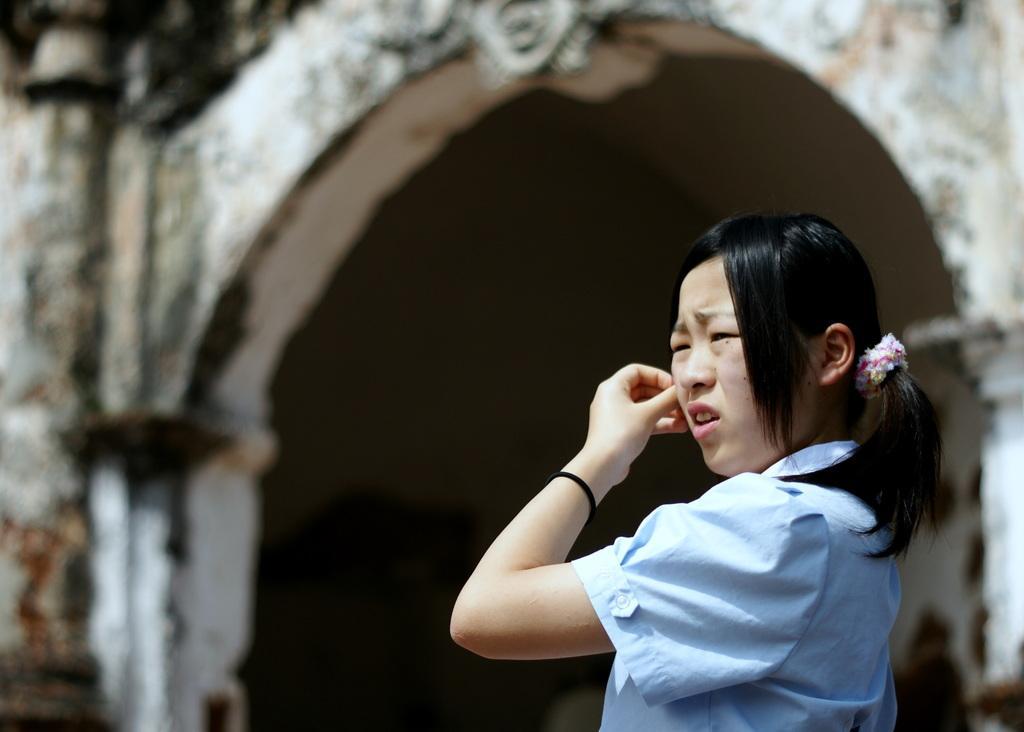How would you summarize this image in a sentence or two? In this picture we can see a girl and in the background we can see an arch, pillars and it is blurry. 